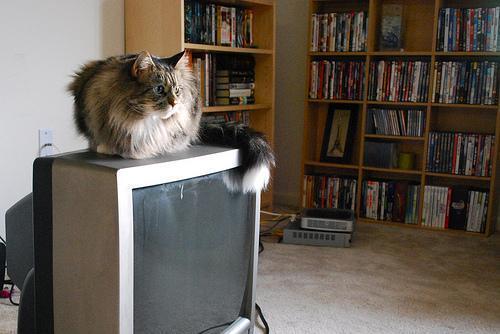How many televisions are in the room?
Give a very brief answer. 1. How many cats are in the photo?
Give a very brief answer. 1. 